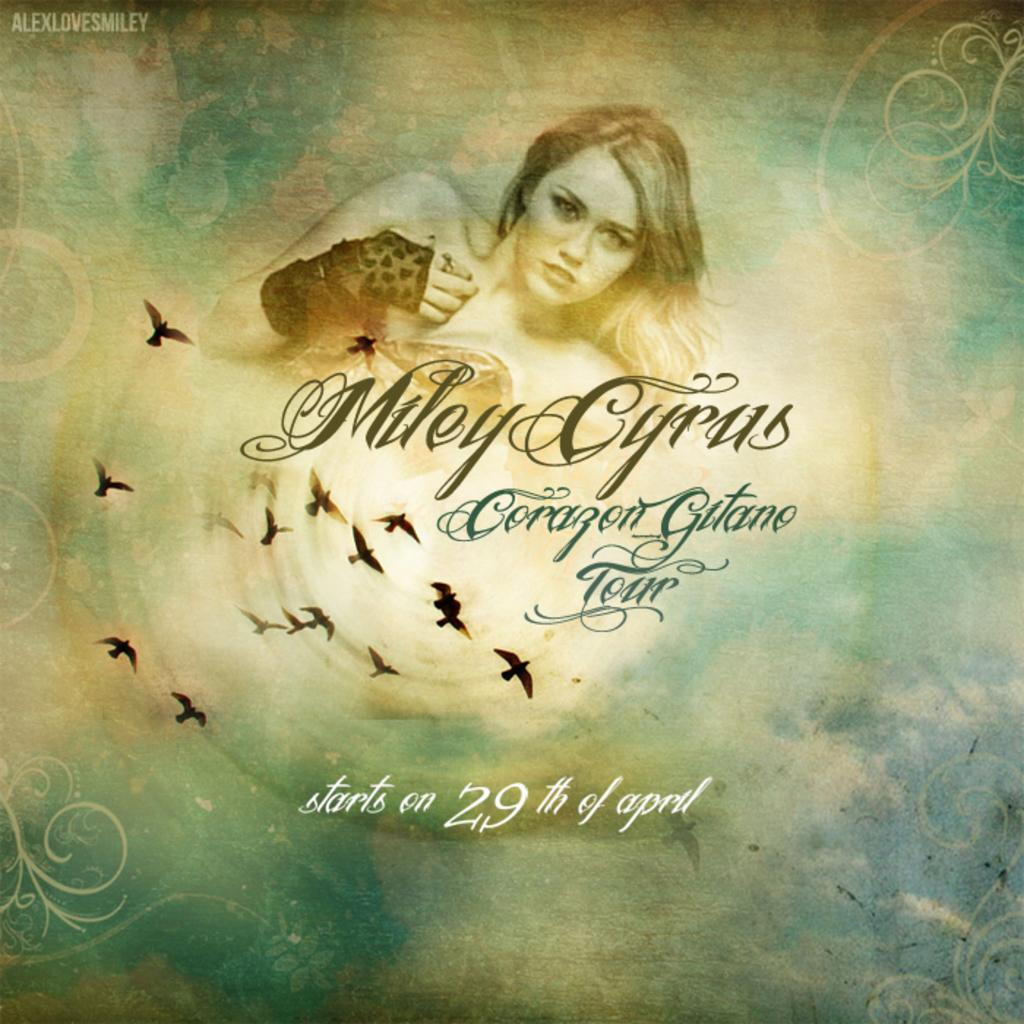<image>
Summarize the visual content of the image. Miley Cyrus is starting a tour on the 29th of April. 